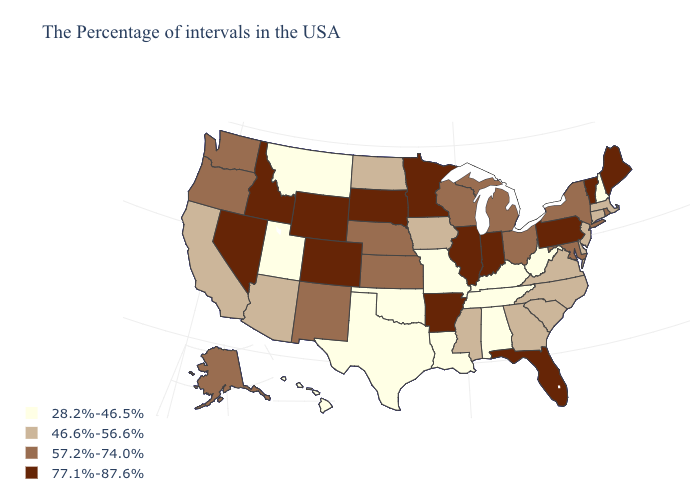What is the highest value in states that border Utah?
Give a very brief answer. 77.1%-87.6%. What is the value of Kansas?
Short answer required. 57.2%-74.0%. What is the lowest value in the South?
Give a very brief answer. 28.2%-46.5%. Does New York have a higher value than Maryland?
Be succinct. No. Does Washington have the lowest value in the West?
Quick response, please. No. Does Virginia have the lowest value in the USA?
Short answer required. No. Among the states that border Pennsylvania , which have the lowest value?
Short answer required. West Virginia. Does Mississippi have a lower value than Vermont?
Short answer required. Yes. What is the lowest value in states that border New Jersey?
Keep it brief. 46.6%-56.6%. Name the states that have a value in the range 28.2%-46.5%?
Be succinct. New Hampshire, West Virginia, Kentucky, Alabama, Tennessee, Louisiana, Missouri, Oklahoma, Texas, Utah, Montana, Hawaii. Does the map have missing data?
Write a very short answer. No. Among the states that border Georgia , which have the highest value?
Concise answer only. Florida. Does Wyoming have the same value as North Carolina?
Concise answer only. No. Name the states that have a value in the range 57.2%-74.0%?
Give a very brief answer. Rhode Island, New York, Maryland, Ohio, Michigan, Wisconsin, Kansas, Nebraska, New Mexico, Washington, Oregon, Alaska. Which states have the lowest value in the USA?
Give a very brief answer. New Hampshire, West Virginia, Kentucky, Alabama, Tennessee, Louisiana, Missouri, Oklahoma, Texas, Utah, Montana, Hawaii. 